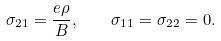Convert formula to latex. <formula><loc_0><loc_0><loc_500><loc_500>\sigma _ { 2 1 } = \frac { e \rho } { B } , \quad \sigma _ { 1 1 } = \sigma _ { 2 2 } = 0 .</formula> 